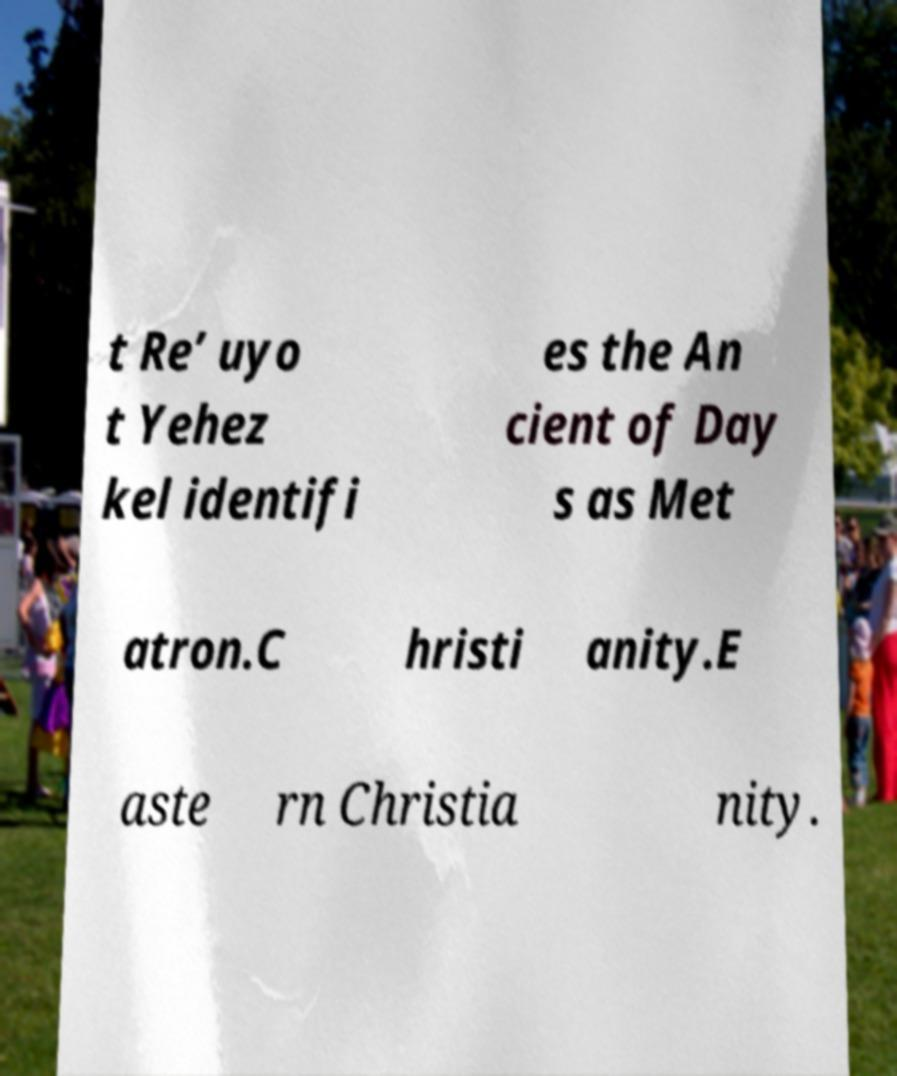Can you accurately transcribe the text from the provided image for me? t Re’ uyo t Yehez kel identifi es the An cient of Day s as Met atron.C hristi anity.E aste rn Christia nity. 